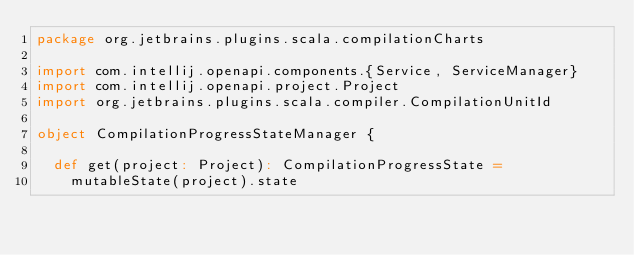<code> <loc_0><loc_0><loc_500><loc_500><_Scala_>package org.jetbrains.plugins.scala.compilationCharts

import com.intellij.openapi.components.{Service, ServiceManager}
import com.intellij.openapi.project.Project
import org.jetbrains.plugins.scala.compiler.CompilationUnitId

object CompilationProgressStateManager {

  def get(project: Project): CompilationProgressState =
    mutableState(project).state
</code> 